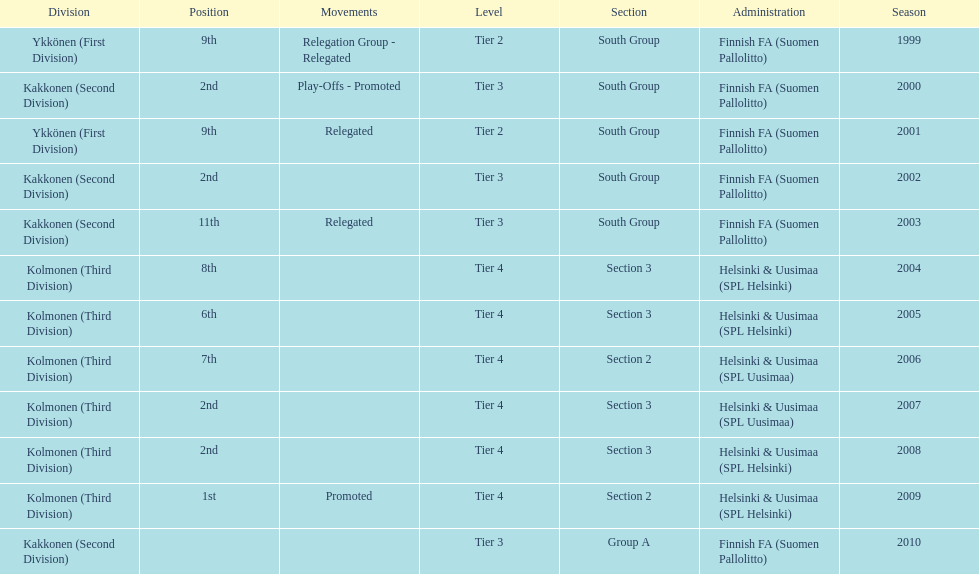What is the first tier listed? Tier 2. 